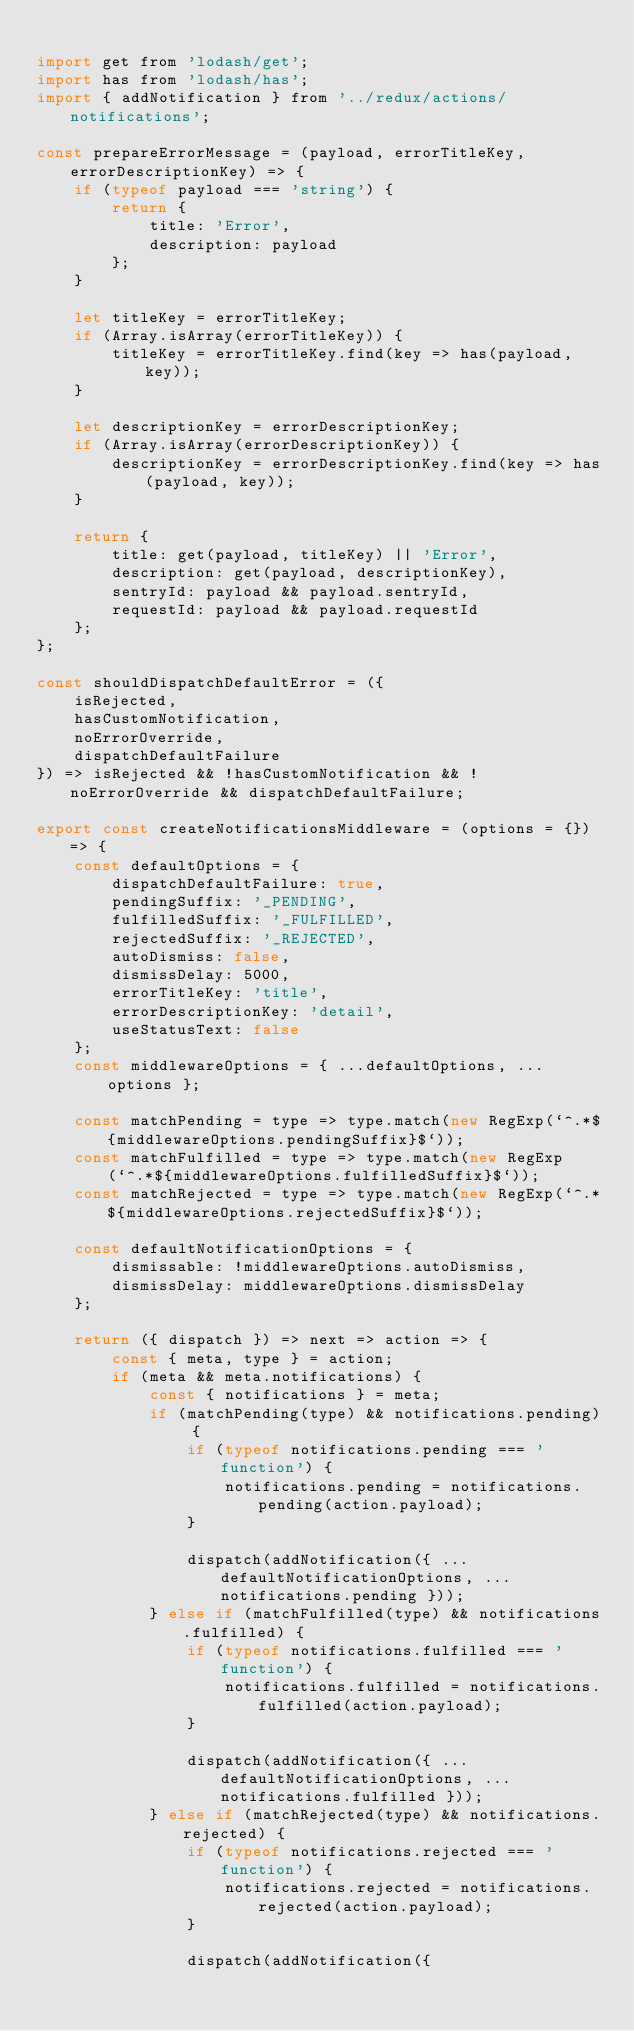<code> <loc_0><loc_0><loc_500><loc_500><_JavaScript_>
import get from 'lodash/get';
import has from 'lodash/has';
import { addNotification } from '../redux/actions/notifications';

const prepareErrorMessage = (payload, errorTitleKey, errorDescriptionKey) => {
    if (typeof payload === 'string') {
        return {
            title: 'Error',
            description: payload
        };
    }

    let titleKey = errorTitleKey;
    if (Array.isArray(errorTitleKey)) {
        titleKey = errorTitleKey.find(key => has(payload, key));
    }

    let descriptionKey = errorDescriptionKey;
    if (Array.isArray(errorDescriptionKey)) {
        descriptionKey = errorDescriptionKey.find(key => has(payload, key));
    }

    return {
        title: get(payload, titleKey) || 'Error',
        description: get(payload, descriptionKey),
        sentryId: payload && payload.sentryId,
        requestId: payload && payload.requestId
    };
};

const shouldDispatchDefaultError = ({
    isRejected,
    hasCustomNotification,
    noErrorOverride,
    dispatchDefaultFailure
}) => isRejected && !hasCustomNotification && !noErrorOverride && dispatchDefaultFailure;

export const createNotificationsMiddleware = (options = {}) => {
    const defaultOptions = {
        dispatchDefaultFailure: true,
        pendingSuffix: '_PENDING',
        fulfilledSuffix: '_FULFILLED',
        rejectedSuffix: '_REJECTED',
        autoDismiss: false,
        dismissDelay: 5000,
        errorTitleKey: 'title',
        errorDescriptionKey: 'detail',
        useStatusText: false
    };
    const middlewareOptions = { ...defaultOptions, ...options };

    const matchPending = type => type.match(new RegExp(`^.*${middlewareOptions.pendingSuffix}$`));
    const matchFulfilled = type => type.match(new RegExp(`^.*${middlewareOptions.fulfilledSuffix}$`));
    const matchRejected = type => type.match(new RegExp(`^.*${middlewareOptions.rejectedSuffix}$`));

    const defaultNotificationOptions = {
        dismissable: !middlewareOptions.autoDismiss,
        dismissDelay: middlewareOptions.dismissDelay
    };

    return ({ dispatch }) => next => action => {
        const { meta, type } = action;
        if (meta && meta.notifications) {
            const { notifications } = meta;
            if (matchPending(type) && notifications.pending) {
                if (typeof notifications.pending === 'function') {
                    notifications.pending = notifications.pending(action.payload);
                }

                dispatch(addNotification({ ...defaultNotificationOptions, ...notifications.pending }));
            } else if (matchFulfilled(type) && notifications.fulfilled) {
                if (typeof notifications.fulfilled === 'function') {
                    notifications.fulfilled = notifications.fulfilled(action.payload);
                }

                dispatch(addNotification({ ...defaultNotificationOptions, ...notifications.fulfilled }));
            } else if (matchRejected(type) && notifications.rejected) {
                if (typeof notifications.rejected === 'function') {
                    notifications.rejected = notifications.rejected(action.payload);
                }

                dispatch(addNotification({</code> 